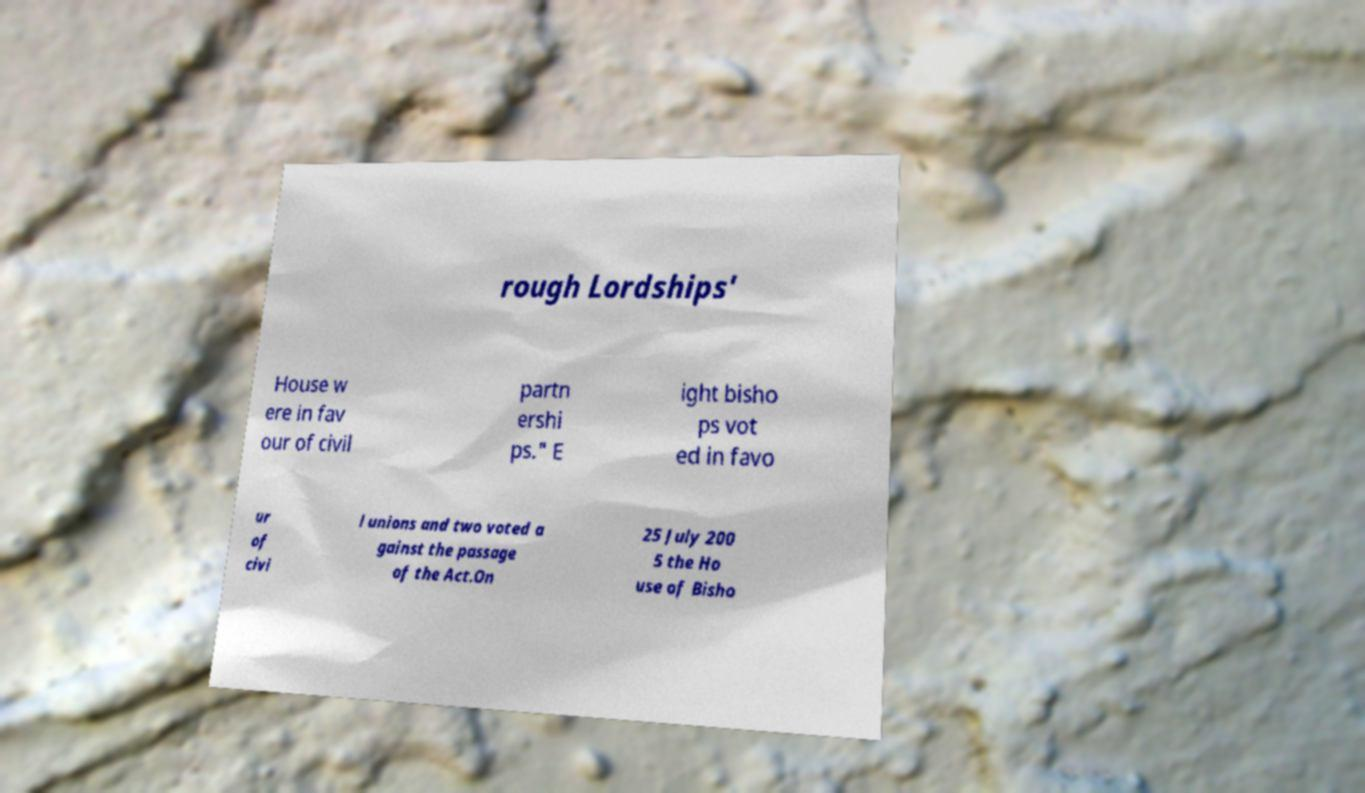For documentation purposes, I need the text within this image transcribed. Could you provide that? rough Lordships' House w ere in fav our of civil partn ershi ps." E ight bisho ps vot ed in favo ur of civi l unions and two voted a gainst the passage of the Act.On 25 July 200 5 the Ho use of Bisho 